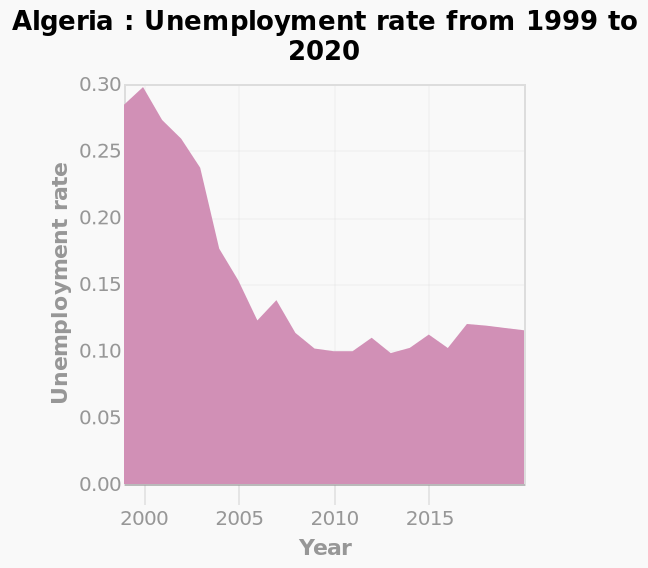<image>
What is the range of years represented on the x-axis of the area plot? The range of years represented on the x-axis of the area plot is from 1999 to 2020. Is the unemployment rate increasing or decreasing over time in Algeria? Without specific data from the area plot, we cannot determine whether the unemployment rate is increasing or decreasing over time in Algeria. 